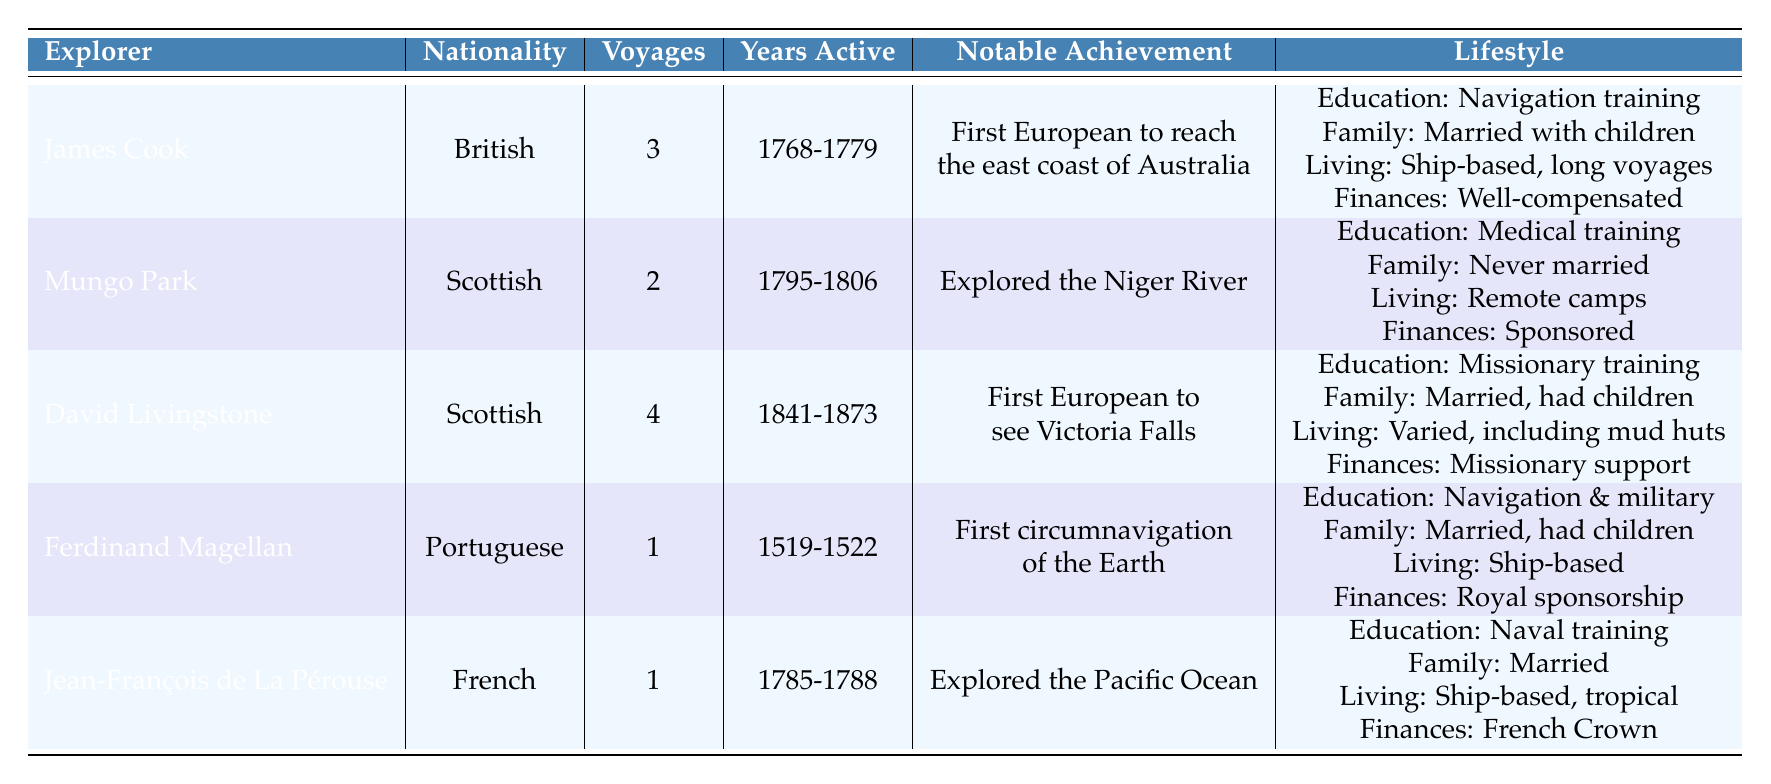What's the nationality of James Cook? James Cook is listed under the nationality column of the table. It directly states that he is British.
Answer: British How many voyages did David Livingstone complete? The table lists David Livingstone under the "Voyages" column, indicating he completed 4 voyages.
Answer: 4 Which explorer achieved the notable feat of exploring the Niger River? The notable achievement for Mungo Park is explicitly mentioned in the table, where it states he explored the Niger River.
Answer: Mungo Park Is it true that Jean-François de La Pérouse was never married? The table provides information under the "Family Status" category for Jean-François de La Pérouse, indicating that he was married. Thus, the statement is false.
Answer: No What is the average number of voyages made by the Scottish explorers? The number of voyages made by Scottish explorers Mungo Park (2) and David Livingstone (4) sums to 6. There are 2 Scottish explorers, so the average is 6/2 = 3.
Answer: 3 Which explorer had the longest active years from the provided data? By analyzing the "Years Active" column, David Livingstone's active years span from 1841 to 1873, totaling 32 years, which is longer than any other listed explorer.
Answer: David Livingstone Did any of the explorers have a lifestyle of living in remote camps during their explorations? The table highlights Mungo Park's lifestyle as including "remote camps during exploration," confirming that he indeed lived in such conditions.
Answer: Yes Among the explorers, who was financially supported primarily by missionary societies? The lifestyle section for David Livingstone mentions that he was financially supported by missionary societies, specifically referring to his unique financial backing among the listed explorers.
Answer: David Livingstone What percentage of explorers in the table were married? There are 5 explorers in total. Four (James Cook, David Livingstone, Ferdinand Magellan, and Jean-François de La Pérouse) are noted as married. Thus, the percentage is (4/5) * 100 = 80%.
Answer: 80% 